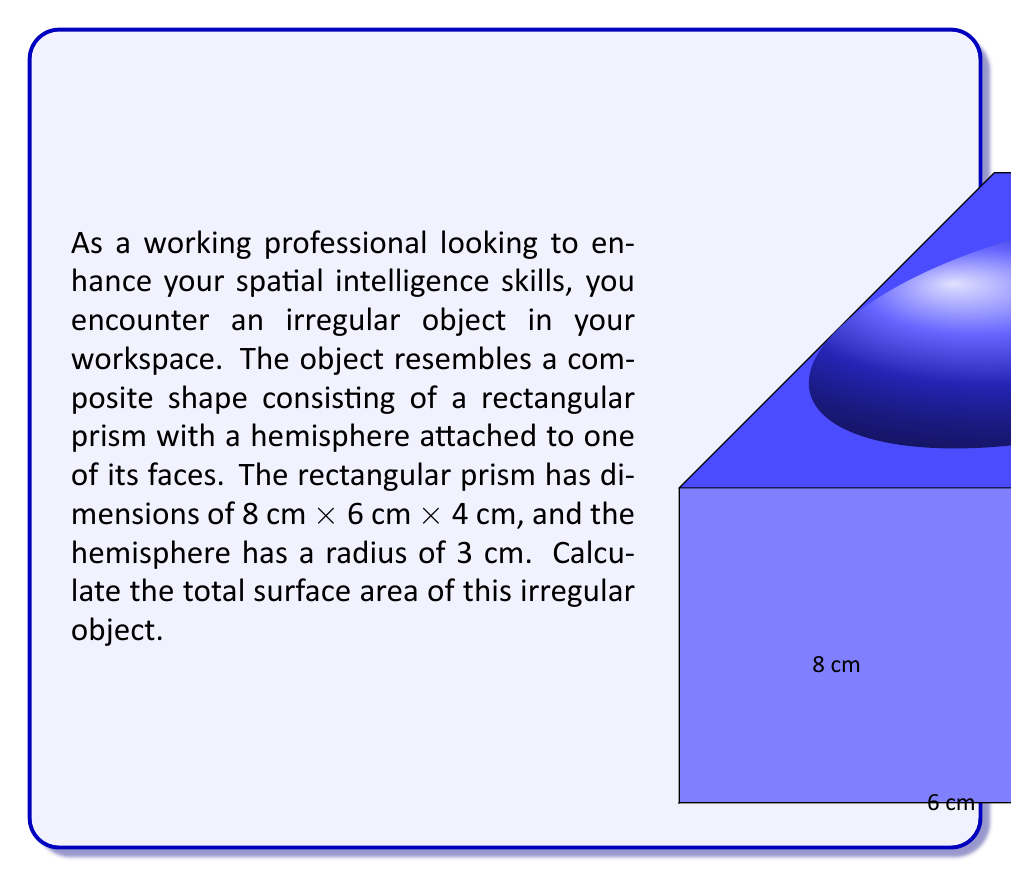Give your solution to this math problem. To calculate the total surface area of this irregular object, we need to:
1. Calculate the surface area of the rectangular prism
2. Calculate the surface area of the hemisphere
3. Subtract the area of the circular base of the hemisphere (as it's not exposed)
4. Sum up the results

Step 1: Surface area of the rectangular prism
The surface area of a rectangular prism is given by the formula:
$$ SA_{prism} = 2(lw + lh + wh) $$
where $l$, $w$, and $h$ are length, width, and height respectively.

$$ SA_{prism} = 2[(8 \times 6) + (8 \times 4) + (6 \times 4)] $$
$$ SA_{prism} = 2(48 + 32 + 24) = 2(104) = 208 \text{ cm}^2 $$

Step 2: Surface area of the hemisphere
The surface area of a hemisphere is given by the formula:
$$ SA_{hemisphere} = 2\pi r^2 $$
where $r$ is the radius.

$$ SA_{hemisphere} = 2\pi (3)^2 = 18\pi \text{ cm}^2 $$

Step 3: Area of the circular base of the hemisphere
We need to subtract this area as it's not exposed:
$$ A_{circle} = \pi r^2 = \pi (3)^2 = 9\pi \text{ cm}^2 $$

Step 4: Total surface area
$$ SA_{total} = SA_{prism} + SA_{hemisphere} - A_{circle} $$
$$ SA_{total} = 208 + 18\pi - 9\pi = 208 + 9\pi \text{ cm}^2 $$
Answer: $208 + 9\pi \text{ cm}^2$ 